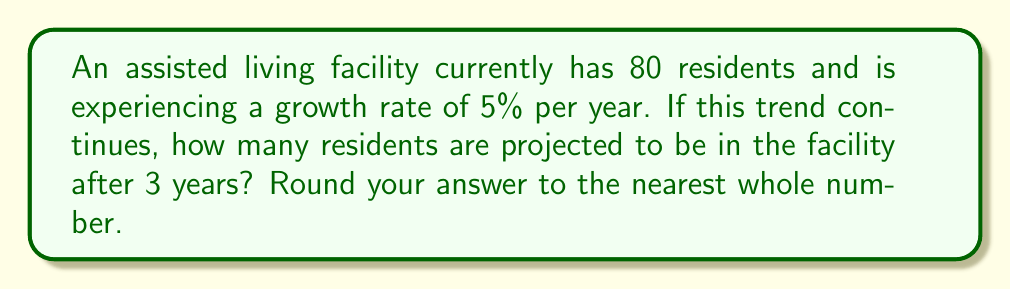Can you solve this math problem? To solve this problem, we'll use the exponential growth model:

$$ A = P(1 + r)^t $$

Where:
$A$ = Final amount
$P$ = Initial amount (principal)
$r$ = Growth rate (as a decimal)
$t$ = Time period

Given:
$P = 80$ (initial number of residents)
$r = 0.05$ (5% growth rate as a decimal)
$t = 3$ years

Let's substitute these values into the formula:

$$ A = 80(1 + 0.05)^3 $$

Now, let's solve step-by-step:

1) First, calculate $(1 + 0.05)^3$:
   $$ (1.05)^3 = 1.157625 $$

2) Multiply this result by the initial number of residents:
   $$ 80 \times 1.157625 = 92.61 $$

3) Round to the nearest whole number:
   $$ 92.61 \approx 93 $$

Therefore, after 3 years, the assisted living facility is projected to have 93 residents.
Answer: 93 residents 